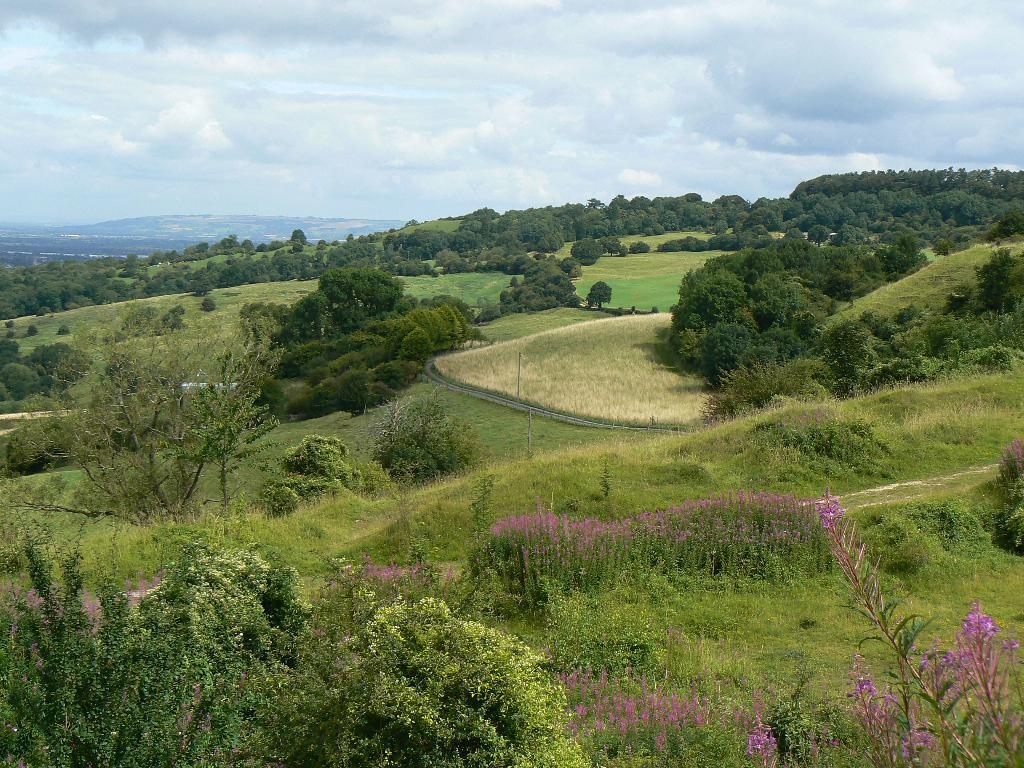Please provide a concise description of this image. In this image we can see trees, plants, flowers, grass, hills, sky and clouds. 